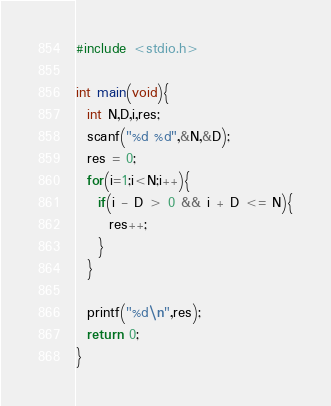Convert code to text. <code><loc_0><loc_0><loc_500><loc_500><_C_>#include <stdio.h>

int main(void){
  int N,D,i,res;
  scanf("%d %d",&N,&D);
  res = 0;
  for(i=1;i<N;i++){
    if(i - D > 0 && i + D <= N){
      res++;
    }
  }

  printf("%d\n",res);
  return 0;
}
</code> 